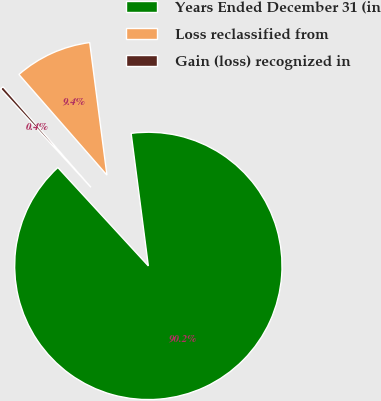<chart> <loc_0><loc_0><loc_500><loc_500><pie_chart><fcel>Years Ended December 31 (in<fcel>Loss reclassified from<fcel>Gain (loss) recognized in<nl><fcel>90.21%<fcel>9.38%<fcel>0.4%<nl></chart> 